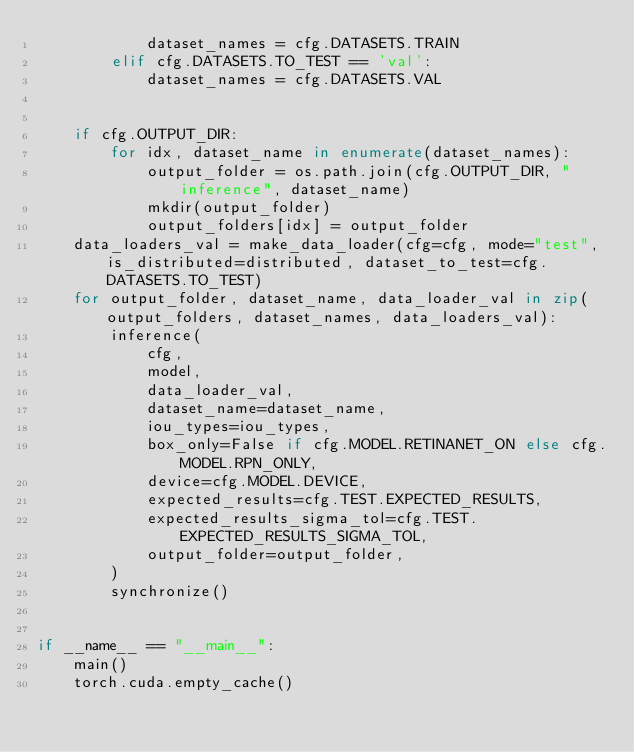<code> <loc_0><loc_0><loc_500><loc_500><_Python_>            dataset_names = cfg.DATASETS.TRAIN
        elif cfg.DATASETS.TO_TEST == 'val':
            dataset_names = cfg.DATASETS.VAL


    if cfg.OUTPUT_DIR:
        for idx, dataset_name in enumerate(dataset_names):
            output_folder = os.path.join(cfg.OUTPUT_DIR, "inference", dataset_name)
            mkdir(output_folder)
            output_folders[idx] = output_folder
    data_loaders_val = make_data_loader(cfg=cfg, mode="test", is_distributed=distributed, dataset_to_test=cfg.DATASETS.TO_TEST)
    for output_folder, dataset_name, data_loader_val in zip(output_folders, dataset_names, data_loaders_val):
        inference(
            cfg,
            model,
            data_loader_val,
            dataset_name=dataset_name,
            iou_types=iou_types,
            box_only=False if cfg.MODEL.RETINANET_ON else cfg.MODEL.RPN_ONLY,
            device=cfg.MODEL.DEVICE,
            expected_results=cfg.TEST.EXPECTED_RESULTS,
            expected_results_sigma_tol=cfg.TEST.EXPECTED_RESULTS_SIGMA_TOL,
            output_folder=output_folder,
        )
        synchronize()


if __name__ == "__main__":
    main()
    torch.cuda.empty_cache()
</code> 